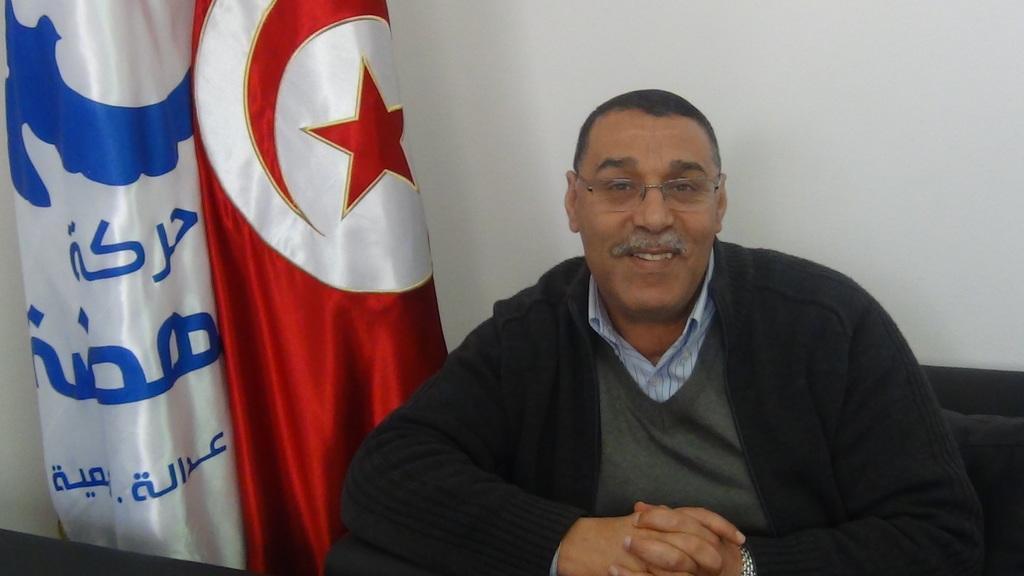Please provide a concise description of this image. In this image there is a man sitting on a couch. Behind him there is a wall. In front of him there is a table. Beside him there are flags. There is text printed on the cloth of the flag. 